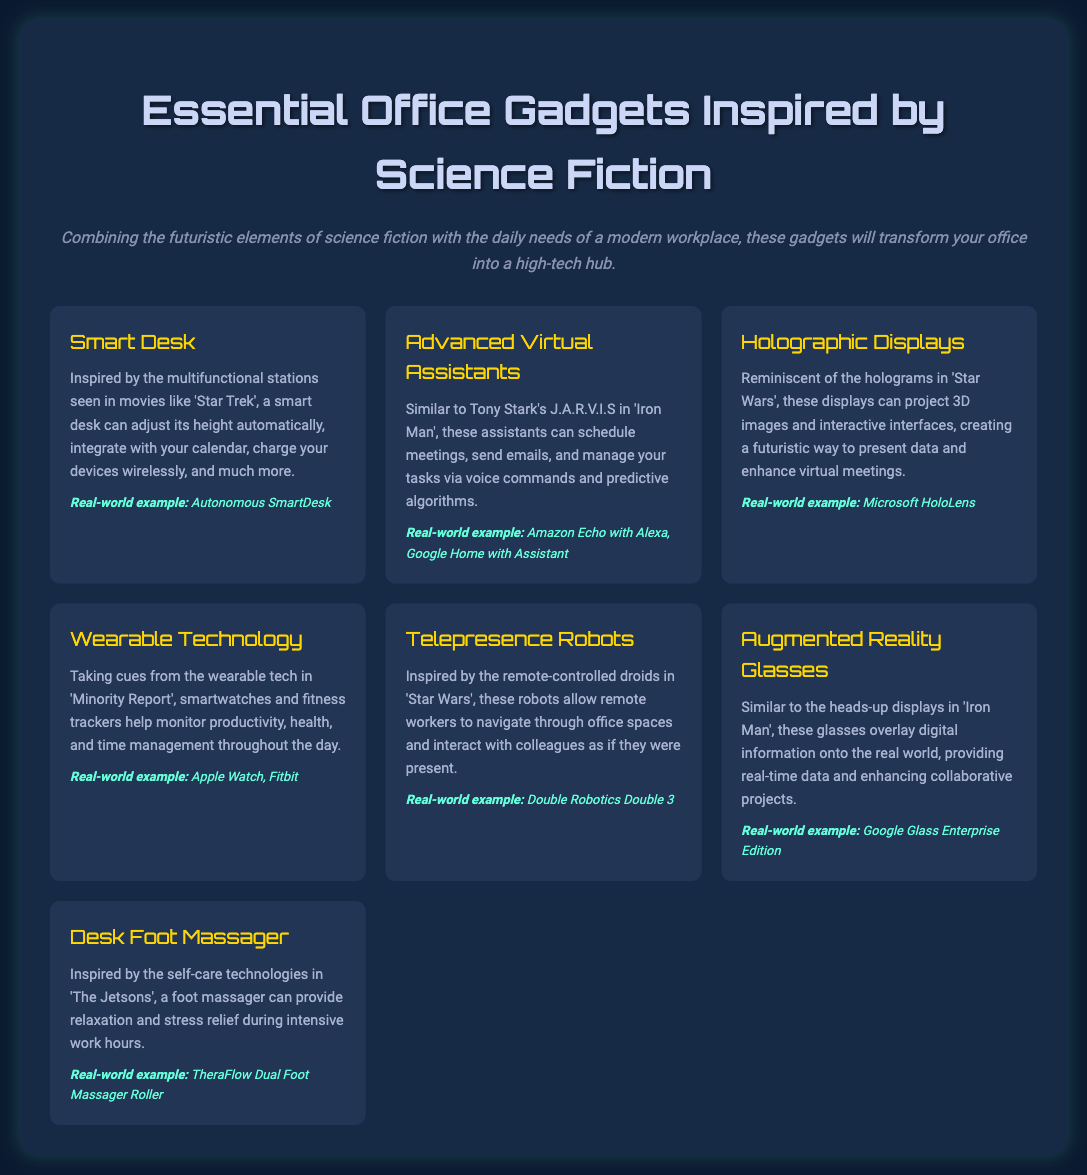What is the title of the document? The title of the document is presented prominently at the top section of the infographic.
Answer: Essential Office Gadgets Inspired by Science Fiction How many gadgets are listed in the document? The document contains a grid of gadgets, detailing a total count listed.
Answer: 7 What gadget is inspired by 'Star Trek'? The document specifies that a certain gadget draws inspiration from a popular sci-fi series.
Answer: Smart Desk Which real-world example is given for Advanced Virtual Assistants? The document includes examples to illustrate the gadgets listed, particularly for this category.
Answer: Amazon Echo with Alexa, Google Home with Assistant What technology allows remote interaction similar to 'Star Wars'? The document references a specific type of gadget that facilitates interaction akin to the sci-fi universe.
Answer: Telepresence Robots Which gadget helps monitor health and productivity? This gadget is designed to assist in tracking health and productivity per the context provided in the infographic.
Answer: Wearable Technology What is the real-world example of Holographic Displays? A specific example is mentioned to define the concept better in the document.
Answer: Microsoft HoloLens What is mentioned as a self-care technology from 'The Jetsons'? The document references a device that promotes relaxation and is influenced by a classic animated series.
Answer: Desk Foot Massager 